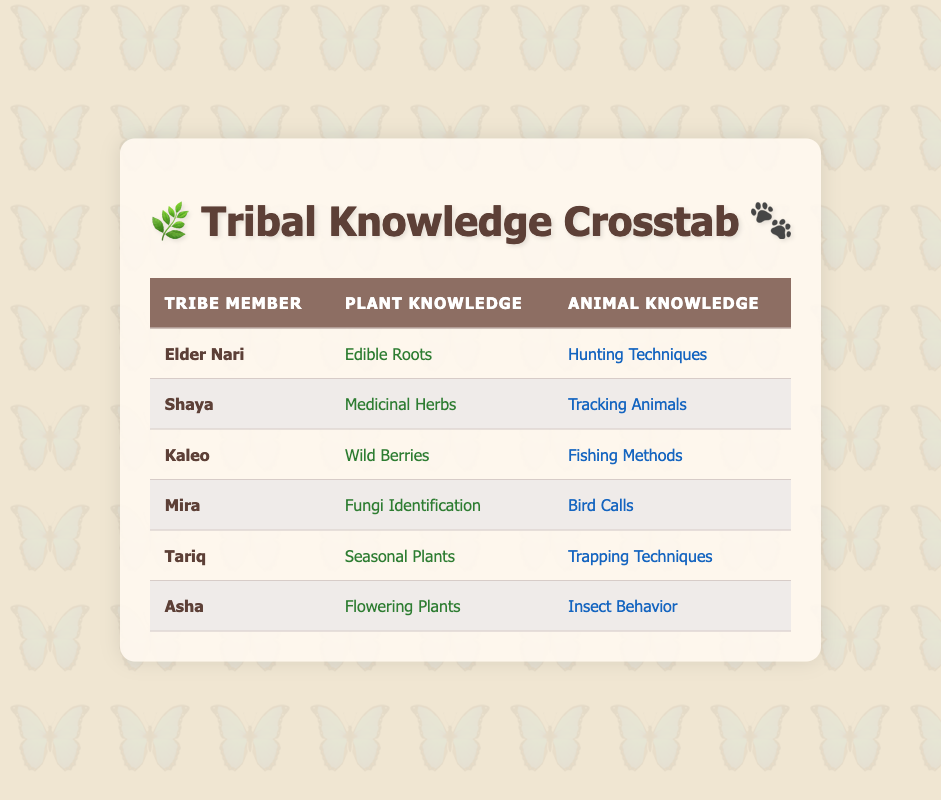What plant knowledge does Elder Nari possess? Elder Nari's plant knowledge is explicitly listed in the table under the "Plant Knowledge" column next to their name. It states "Edible Roots."
Answer: Edible Roots Which tribe member has knowledge of tracking animals? To find the answer, look under the "Animal Knowledge" column and identify the member associated with "Tracking Animals." This information corresponds to Shaya.
Answer: Shaya How many tribe members know about fishing methods? The table lists the animal knowledge of each member. By reviewing the information, we find that only Kaleo mentions "Fishing Methods," thus only one member has this knowledge.
Answer: One Is it true that Asha has knowledge about flowering plants? The table clearly states Asha's plant knowledge in connection to their name, stating "Flowering Plants." Hence, it is indeed true.
Answer: Yes Which two tribe members know about edible plant sources and hunting techniques? Start by examining the "Plant Knowledge" column for "Edible Roots," which corresponds to Elder Nari. Then check the "Animal Knowledge" column for "Hunting Techniques," also belonging to Elder Nari, thus confirming both pieces of knowledge are attributed to him.
Answer: Elder Nari What is the combined knowledge of plant and animal for Tariq? To calculate this, we refer to Tariq's row in the table. Tariq's plant knowledge is "Seasonal Plants," and his animal knowledge is "Trapping Techniques." Thus, the combined knowledge consists of two different but significant contributions.
Answer: Seasonal Plants and Trapping Techniques Which tribe member has the most diverse types of plant knowledge? As we evaluate the table, we need to list the various types of plant knowledge for all tribe members. Each member possesses a unique type of plant knowledge, confirming that none holds multiple types, so no member stands out for diversity in plant knowledge.
Answer: None Mira knows about which animal knowledge? The table has a direct reference to Mira's animal knowledge, where it is explicitly stated as "Bird Calls." This allows for straightforward retrieval of the necessary information.
Answer: Bird Calls How many different types of animal knowledge are represented in the table? By reviewing the "Animal Knowledge" column and identifying unique types mentioned, we see "Hunting Techniques," "Tracking Animals," "Fishing Methods," "Bird Calls," "Trapping Techniques," and "Insect Behavior." We find there are six distinct animal knowledge types in total.
Answer: Six 